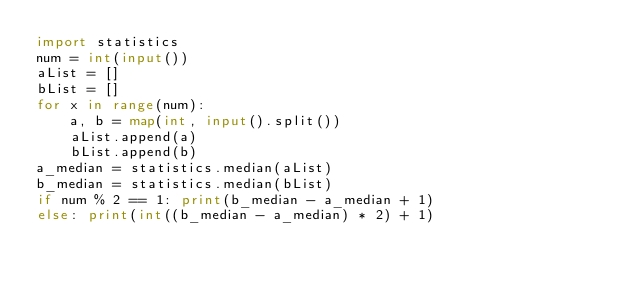Convert code to text. <code><loc_0><loc_0><loc_500><loc_500><_Python_>import statistics
num = int(input())
aList = []
bList = []
for x in range(num):
    a, b = map(int, input().split())
    aList.append(a)
    bList.append(b)
a_median = statistics.median(aList)
b_median = statistics.median(bList)
if num % 2 == 1: print(b_median - a_median + 1)
else: print(int((b_median - a_median) * 2) + 1)
</code> 